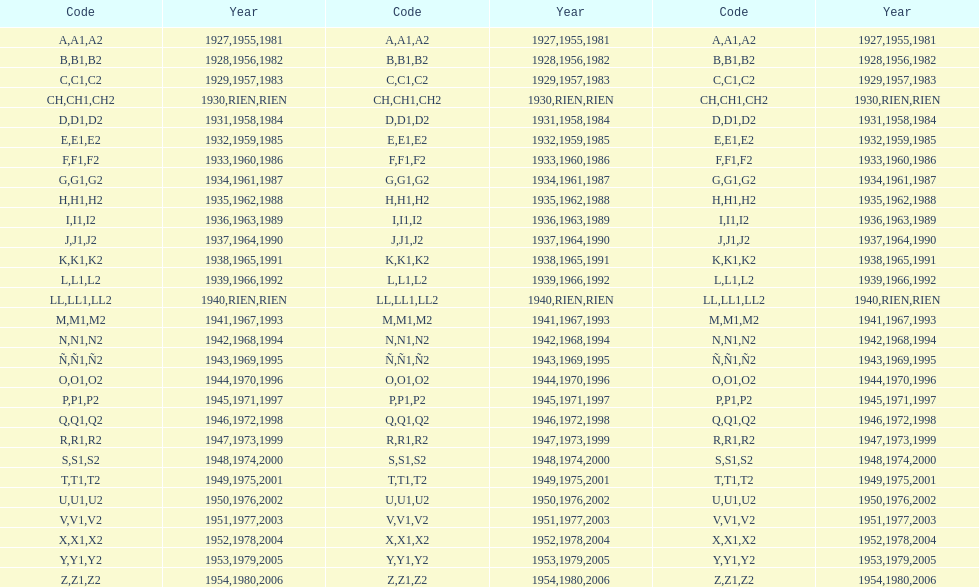How many various codes were employed from 1953 to 1958? 6. 